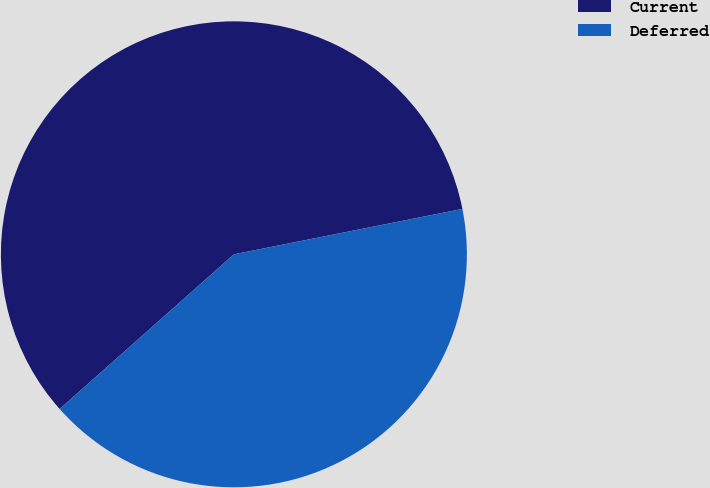Convert chart to OTSL. <chart><loc_0><loc_0><loc_500><loc_500><pie_chart><fcel>Current<fcel>Deferred<nl><fcel>58.43%<fcel>41.57%<nl></chart> 